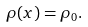<formula> <loc_0><loc_0><loc_500><loc_500>\rho ( x ) = \rho _ { 0 } .</formula> 